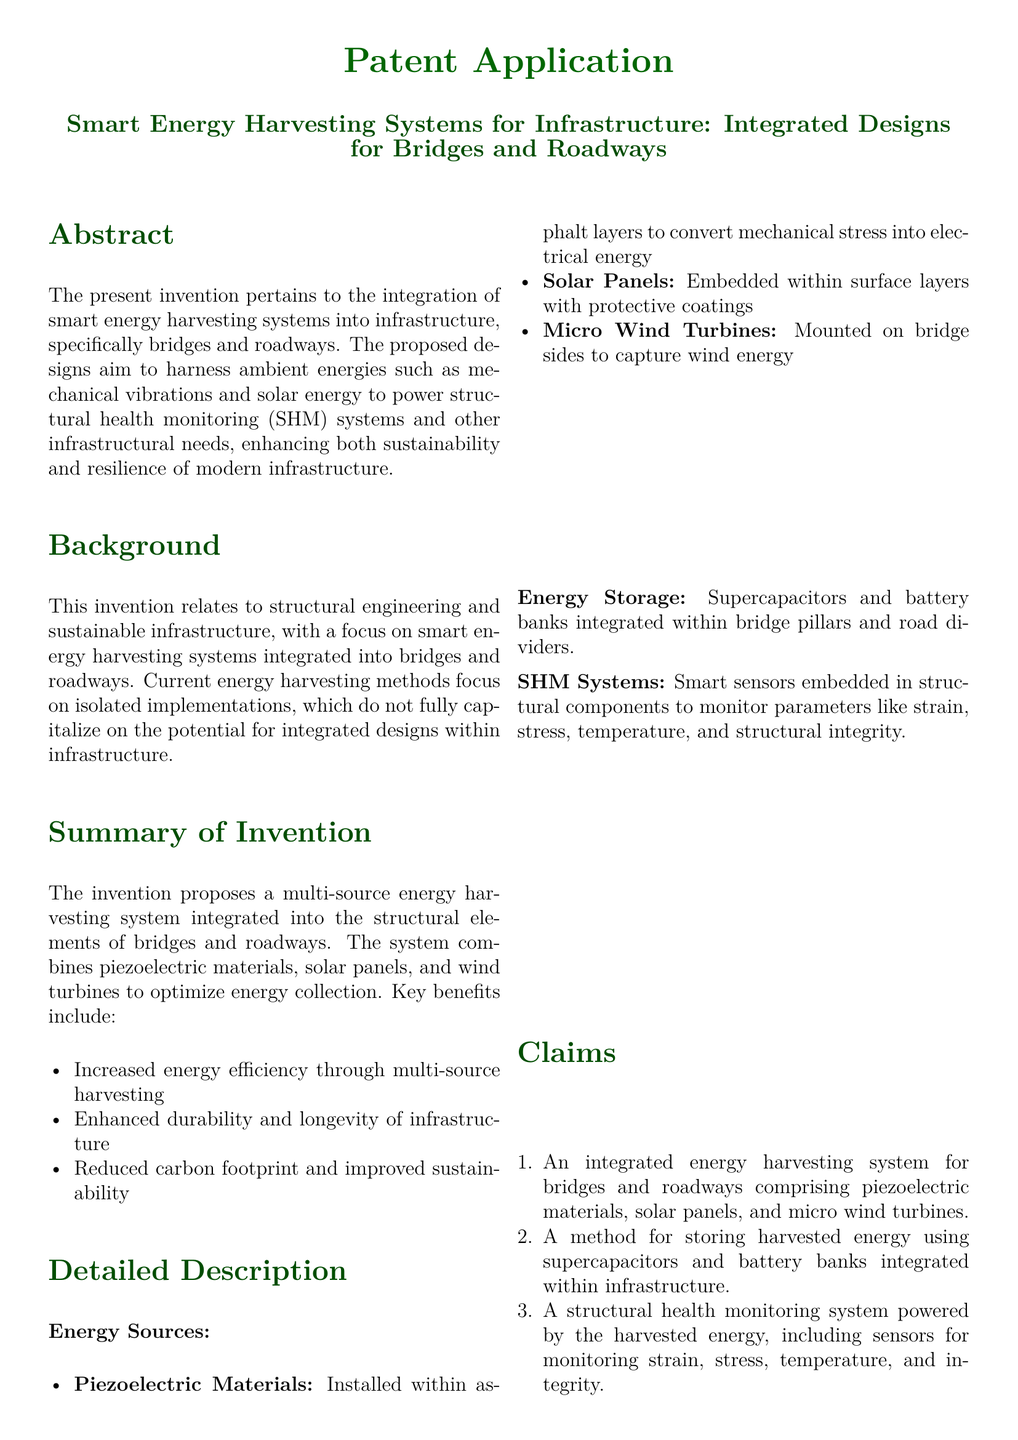what is the title of the patent application? The title of the patent application is found in the center of the document under the heading.
Answer: Smart Energy Harvesting Systems for Infrastructure: Integrated Designs for Bridges and Roadways what are the main energy sources used in the invention? The main energy sources are listed in the detailed description of the document.
Answer: Piezoelectric Materials, Solar Panels, Micro Wind Turbines who is the inventor? The inventor is specified at the end of the document in the section titled "Inventor."
Answer: Un ingeniero estructural que se especializa en la construcción de infraestructuras sostenibles what is one of the benefits of the proposed energy harvesting system? The benefits are outlined in the summary of the invention section.
Answer: Increased energy efficiency through multi-source harvesting what materials are used for energy storage in the system? The materials used for energy storage are mentioned in the detailed description.
Answer: Supercapacitors and battery banks how many claims are made in the patent application? The number of claims is found in the claims section of the document.
Answer: Three what parameters do the structural health monitoring systems measure? The parameters are listed under the detailed description of SHM systems.
Answer: Strain, stress, temperature, integrity what is the purpose of the solar panels in the designs? The purpose of the solar panels is described in the detailed description of energy sources.
Answer: To capture solar energy what is the main focus of the background section? The focus of the background section provides context for the invention's relevance.
Answer: Structural engineering and sustainable infrastructure 